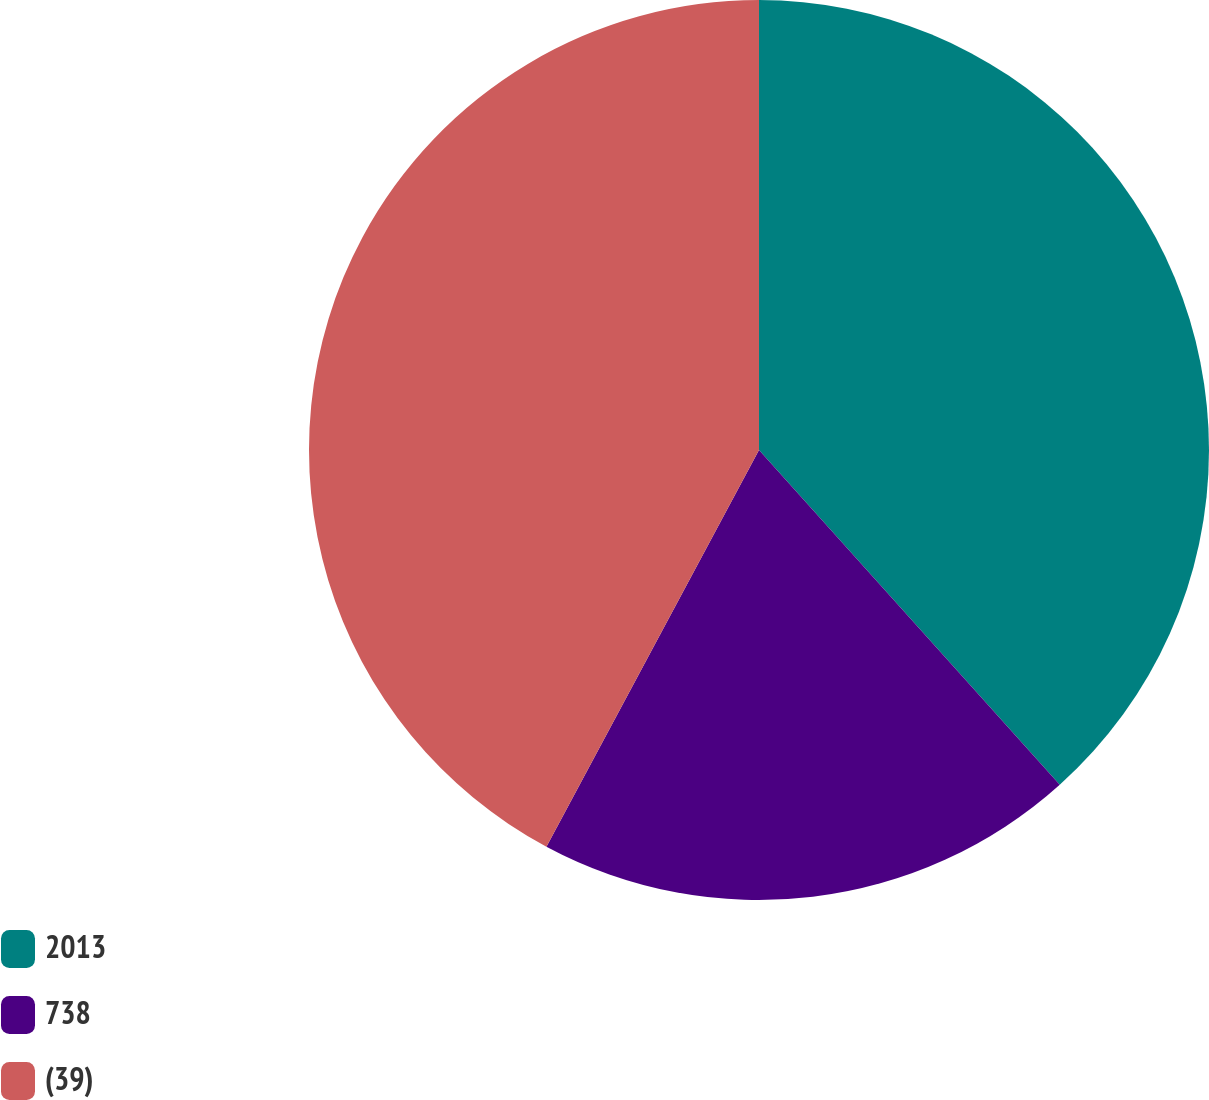Convert chart. <chart><loc_0><loc_0><loc_500><loc_500><pie_chart><fcel>2013<fcel>738<fcel>(39)<nl><fcel>38.35%<fcel>19.48%<fcel>42.17%<nl></chart> 